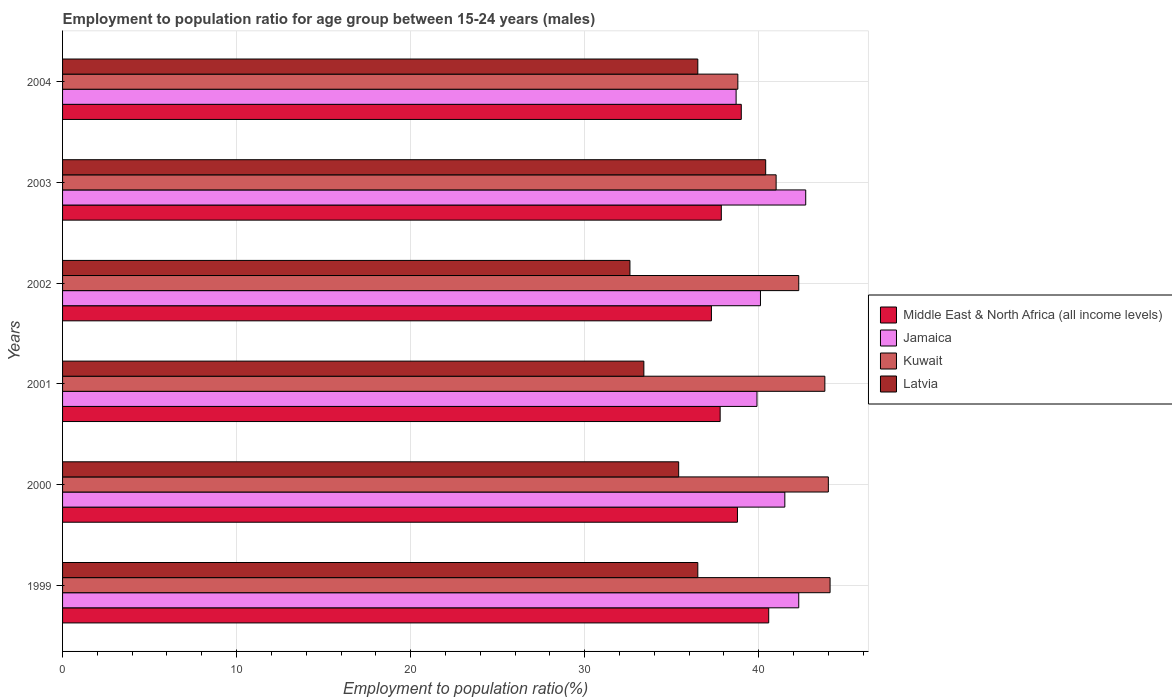How many different coloured bars are there?
Make the answer very short. 4. How many groups of bars are there?
Provide a succinct answer. 6. Are the number of bars on each tick of the Y-axis equal?
Offer a terse response. Yes. What is the label of the 2nd group of bars from the top?
Ensure brevity in your answer.  2003. In how many cases, is the number of bars for a given year not equal to the number of legend labels?
Your answer should be very brief. 0. What is the employment to population ratio in Kuwait in 2003?
Provide a succinct answer. 41. Across all years, what is the maximum employment to population ratio in Middle East & North Africa (all income levels)?
Ensure brevity in your answer.  40.57. Across all years, what is the minimum employment to population ratio in Middle East & North Africa (all income levels)?
Provide a succinct answer. 37.28. In which year was the employment to population ratio in Jamaica minimum?
Keep it short and to the point. 2004. What is the total employment to population ratio in Jamaica in the graph?
Provide a short and direct response. 245.2. What is the difference between the employment to population ratio in Kuwait in 2002 and that in 2003?
Provide a succinct answer. 1.3. What is the difference between the employment to population ratio in Kuwait in 2004 and the employment to population ratio in Latvia in 1999?
Offer a very short reply. 2.3. What is the average employment to population ratio in Latvia per year?
Keep it short and to the point. 35.8. In the year 2003, what is the difference between the employment to population ratio in Middle East & North Africa (all income levels) and employment to population ratio in Kuwait?
Your answer should be compact. -3.15. In how many years, is the employment to population ratio in Latvia greater than 42 %?
Give a very brief answer. 0. What is the ratio of the employment to population ratio in Jamaica in 2002 to that in 2004?
Keep it short and to the point. 1.04. Is the employment to population ratio in Kuwait in 2000 less than that in 2002?
Make the answer very short. No. What is the difference between the highest and the second highest employment to population ratio in Middle East & North Africa (all income levels)?
Give a very brief answer. 1.58. What is the difference between the highest and the lowest employment to population ratio in Latvia?
Offer a terse response. 7.8. Is the sum of the employment to population ratio in Jamaica in 2000 and 2004 greater than the maximum employment to population ratio in Middle East & North Africa (all income levels) across all years?
Provide a succinct answer. Yes. Is it the case that in every year, the sum of the employment to population ratio in Latvia and employment to population ratio in Kuwait is greater than the sum of employment to population ratio in Middle East & North Africa (all income levels) and employment to population ratio in Jamaica?
Provide a short and direct response. No. What does the 4th bar from the top in 2003 represents?
Provide a short and direct response. Middle East & North Africa (all income levels). What does the 3rd bar from the bottom in 2000 represents?
Offer a terse response. Kuwait. Is it the case that in every year, the sum of the employment to population ratio in Jamaica and employment to population ratio in Latvia is greater than the employment to population ratio in Middle East & North Africa (all income levels)?
Keep it short and to the point. Yes. What is the difference between two consecutive major ticks on the X-axis?
Offer a very short reply. 10. Does the graph contain any zero values?
Your answer should be compact. No. Does the graph contain grids?
Ensure brevity in your answer.  Yes. What is the title of the graph?
Provide a short and direct response. Employment to population ratio for age group between 15-24 years (males). What is the label or title of the Y-axis?
Your answer should be compact. Years. What is the Employment to population ratio(%) in Middle East & North Africa (all income levels) in 1999?
Keep it short and to the point. 40.57. What is the Employment to population ratio(%) in Jamaica in 1999?
Ensure brevity in your answer.  42.3. What is the Employment to population ratio(%) of Kuwait in 1999?
Offer a terse response. 44.1. What is the Employment to population ratio(%) in Latvia in 1999?
Provide a succinct answer. 36.5. What is the Employment to population ratio(%) in Middle East & North Africa (all income levels) in 2000?
Your answer should be very brief. 38.78. What is the Employment to population ratio(%) of Jamaica in 2000?
Provide a short and direct response. 41.5. What is the Employment to population ratio(%) in Kuwait in 2000?
Offer a terse response. 44. What is the Employment to population ratio(%) in Latvia in 2000?
Give a very brief answer. 35.4. What is the Employment to population ratio(%) in Middle East & North Africa (all income levels) in 2001?
Provide a succinct answer. 37.78. What is the Employment to population ratio(%) in Jamaica in 2001?
Keep it short and to the point. 39.9. What is the Employment to population ratio(%) of Kuwait in 2001?
Ensure brevity in your answer.  43.8. What is the Employment to population ratio(%) in Latvia in 2001?
Offer a terse response. 33.4. What is the Employment to population ratio(%) in Middle East & North Africa (all income levels) in 2002?
Give a very brief answer. 37.28. What is the Employment to population ratio(%) of Jamaica in 2002?
Offer a terse response. 40.1. What is the Employment to population ratio(%) in Kuwait in 2002?
Your answer should be compact. 42.3. What is the Employment to population ratio(%) in Latvia in 2002?
Provide a short and direct response. 32.6. What is the Employment to population ratio(%) of Middle East & North Africa (all income levels) in 2003?
Offer a terse response. 37.85. What is the Employment to population ratio(%) of Jamaica in 2003?
Keep it short and to the point. 42.7. What is the Employment to population ratio(%) of Kuwait in 2003?
Your answer should be very brief. 41. What is the Employment to population ratio(%) in Latvia in 2003?
Offer a terse response. 40.4. What is the Employment to population ratio(%) of Middle East & North Africa (all income levels) in 2004?
Make the answer very short. 39. What is the Employment to population ratio(%) of Jamaica in 2004?
Provide a short and direct response. 38.7. What is the Employment to population ratio(%) of Kuwait in 2004?
Your answer should be very brief. 38.8. What is the Employment to population ratio(%) in Latvia in 2004?
Ensure brevity in your answer.  36.5. Across all years, what is the maximum Employment to population ratio(%) of Middle East & North Africa (all income levels)?
Your response must be concise. 40.57. Across all years, what is the maximum Employment to population ratio(%) of Jamaica?
Provide a succinct answer. 42.7. Across all years, what is the maximum Employment to population ratio(%) of Kuwait?
Provide a succinct answer. 44.1. Across all years, what is the maximum Employment to population ratio(%) in Latvia?
Your response must be concise. 40.4. Across all years, what is the minimum Employment to population ratio(%) of Middle East & North Africa (all income levels)?
Your response must be concise. 37.28. Across all years, what is the minimum Employment to population ratio(%) of Jamaica?
Your answer should be very brief. 38.7. Across all years, what is the minimum Employment to population ratio(%) in Kuwait?
Provide a short and direct response. 38.8. Across all years, what is the minimum Employment to population ratio(%) of Latvia?
Make the answer very short. 32.6. What is the total Employment to population ratio(%) of Middle East & North Africa (all income levels) in the graph?
Offer a terse response. 231.26. What is the total Employment to population ratio(%) of Jamaica in the graph?
Your response must be concise. 245.2. What is the total Employment to population ratio(%) in Kuwait in the graph?
Make the answer very short. 254. What is the total Employment to population ratio(%) of Latvia in the graph?
Make the answer very short. 214.8. What is the difference between the Employment to population ratio(%) in Middle East & North Africa (all income levels) in 1999 and that in 2000?
Keep it short and to the point. 1.8. What is the difference between the Employment to population ratio(%) of Jamaica in 1999 and that in 2000?
Offer a very short reply. 0.8. What is the difference between the Employment to population ratio(%) in Middle East & North Africa (all income levels) in 1999 and that in 2001?
Provide a succinct answer. 2.79. What is the difference between the Employment to population ratio(%) of Jamaica in 1999 and that in 2001?
Give a very brief answer. 2.4. What is the difference between the Employment to population ratio(%) of Kuwait in 1999 and that in 2001?
Ensure brevity in your answer.  0.3. What is the difference between the Employment to population ratio(%) in Middle East & North Africa (all income levels) in 1999 and that in 2002?
Make the answer very short. 3.29. What is the difference between the Employment to population ratio(%) of Jamaica in 1999 and that in 2002?
Offer a terse response. 2.2. What is the difference between the Employment to population ratio(%) of Kuwait in 1999 and that in 2002?
Keep it short and to the point. 1.8. What is the difference between the Employment to population ratio(%) of Latvia in 1999 and that in 2002?
Your response must be concise. 3.9. What is the difference between the Employment to population ratio(%) of Middle East & North Africa (all income levels) in 1999 and that in 2003?
Your answer should be very brief. 2.72. What is the difference between the Employment to population ratio(%) of Jamaica in 1999 and that in 2003?
Provide a short and direct response. -0.4. What is the difference between the Employment to population ratio(%) of Middle East & North Africa (all income levels) in 1999 and that in 2004?
Provide a short and direct response. 1.58. What is the difference between the Employment to population ratio(%) of Kuwait in 1999 and that in 2004?
Provide a succinct answer. 5.3. What is the difference between the Employment to population ratio(%) of Latvia in 1999 and that in 2004?
Provide a succinct answer. 0. What is the difference between the Employment to population ratio(%) in Jamaica in 2000 and that in 2001?
Your response must be concise. 1.6. What is the difference between the Employment to population ratio(%) in Latvia in 2000 and that in 2001?
Ensure brevity in your answer.  2. What is the difference between the Employment to population ratio(%) of Middle East & North Africa (all income levels) in 2000 and that in 2002?
Your answer should be compact. 1.5. What is the difference between the Employment to population ratio(%) of Jamaica in 2000 and that in 2002?
Provide a succinct answer. 1.4. What is the difference between the Employment to population ratio(%) in Kuwait in 2000 and that in 2002?
Offer a very short reply. 1.7. What is the difference between the Employment to population ratio(%) of Latvia in 2000 and that in 2002?
Your answer should be compact. 2.8. What is the difference between the Employment to population ratio(%) of Middle East & North Africa (all income levels) in 2000 and that in 2003?
Keep it short and to the point. 0.93. What is the difference between the Employment to population ratio(%) of Latvia in 2000 and that in 2003?
Provide a short and direct response. -5. What is the difference between the Employment to population ratio(%) in Middle East & North Africa (all income levels) in 2000 and that in 2004?
Offer a terse response. -0.22. What is the difference between the Employment to population ratio(%) of Kuwait in 2000 and that in 2004?
Keep it short and to the point. 5.2. What is the difference between the Employment to population ratio(%) in Middle East & North Africa (all income levels) in 2001 and that in 2002?
Keep it short and to the point. 0.5. What is the difference between the Employment to population ratio(%) of Latvia in 2001 and that in 2002?
Make the answer very short. 0.8. What is the difference between the Employment to population ratio(%) of Middle East & North Africa (all income levels) in 2001 and that in 2003?
Your response must be concise. -0.07. What is the difference between the Employment to population ratio(%) of Kuwait in 2001 and that in 2003?
Ensure brevity in your answer.  2.8. What is the difference between the Employment to population ratio(%) of Middle East & North Africa (all income levels) in 2001 and that in 2004?
Your answer should be compact. -1.21. What is the difference between the Employment to population ratio(%) of Jamaica in 2001 and that in 2004?
Give a very brief answer. 1.2. What is the difference between the Employment to population ratio(%) in Middle East & North Africa (all income levels) in 2002 and that in 2003?
Ensure brevity in your answer.  -0.57. What is the difference between the Employment to population ratio(%) of Kuwait in 2002 and that in 2003?
Offer a very short reply. 1.3. What is the difference between the Employment to population ratio(%) of Latvia in 2002 and that in 2003?
Make the answer very short. -7.8. What is the difference between the Employment to population ratio(%) of Middle East & North Africa (all income levels) in 2002 and that in 2004?
Make the answer very short. -1.72. What is the difference between the Employment to population ratio(%) in Jamaica in 2002 and that in 2004?
Ensure brevity in your answer.  1.4. What is the difference between the Employment to population ratio(%) in Kuwait in 2002 and that in 2004?
Offer a very short reply. 3.5. What is the difference between the Employment to population ratio(%) in Latvia in 2002 and that in 2004?
Provide a succinct answer. -3.9. What is the difference between the Employment to population ratio(%) in Middle East & North Africa (all income levels) in 2003 and that in 2004?
Ensure brevity in your answer.  -1.15. What is the difference between the Employment to population ratio(%) of Jamaica in 2003 and that in 2004?
Your answer should be compact. 4. What is the difference between the Employment to population ratio(%) in Middle East & North Africa (all income levels) in 1999 and the Employment to population ratio(%) in Jamaica in 2000?
Make the answer very short. -0.93. What is the difference between the Employment to population ratio(%) of Middle East & North Africa (all income levels) in 1999 and the Employment to population ratio(%) of Kuwait in 2000?
Give a very brief answer. -3.43. What is the difference between the Employment to population ratio(%) of Middle East & North Africa (all income levels) in 1999 and the Employment to population ratio(%) of Latvia in 2000?
Provide a short and direct response. 5.17. What is the difference between the Employment to population ratio(%) of Jamaica in 1999 and the Employment to population ratio(%) of Latvia in 2000?
Your response must be concise. 6.9. What is the difference between the Employment to population ratio(%) of Kuwait in 1999 and the Employment to population ratio(%) of Latvia in 2000?
Offer a terse response. 8.7. What is the difference between the Employment to population ratio(%) of Middle East & North Africa (all income levels) in 1999 and the Employment to population ratio(%) of Jamaica in 2001?
Make the answer very short. 0.67. What is the difference between the Employment to population ratio(%) in Middle East & North Africa (all income levels) in 1999 and the Employment to population ratio(%) in Kuwait in 2001?
Your answer should be very brief. -3.23. What is the difference between the Employment to population ratio(%) in Middle East & North Africa (all income levels) in 1999 and the Employment to population ratio(%) in Latvia in 2001?
Ensure brevity in your answer.  7.17. What is the difference between the Employment to population ratio(%) in Jamaica in 1999 and the Employment to population ratio(%) in Latvia in 2001?
Ensure brevity in your answer.  8.9. What is the difference between the Employment to population ratio(%) in Middle East & North Africa (all income levels) in 1999 and the Employment to population ratio(%) in Jamaica in 2002?
Make the answer very short. 0.47. What is the difference between the Employment to population ratio(%) in Middle East & North Africa (all income levels) in 1999 and the Employment to population ratio(%) in Kuwait in 2002?
Your answer should be very brief. -1.73. What is the difference between the Employment to population ratio(%) of Middle East & North Africa (all income levels) in 1999 and the Employment to population ratio(%) of Latvia in 2002?
Your answer should be very brief. 7.97. What is the difference between the Employment to population ratio(%) of Kuwait in 1999 and the Employment to population ratio(%) of Latvia in 2002?
Ensure brevity in your answer.  11.5. What is the difference between the Employment to population ratio(%) of Middle East & North Africa (all income levels) in 1999 and the Employment to population ratio(%) of Jamaica in 2003?
Your response must be concise. -2.13. What is the difference between the Employment to population ratio(%) of Middle East & North Africa (all income levels) in 1999 and the Employment to population ratio(%) of Kuwait in 2003?
Provide a succinct answer. -0.43. What is the difference between the Employment to population ratio(%) in Middle East & North Africa (all income levels) in 1999 and the Employment to population ratio(%) in Latvia in 2003?
Provide a succinct answer. 0.17. What is the difference between the Employment to population ratio(%) of Jamaica in 1999 and the Employment to population ratio(%) of Kuwait in 2003?
Offer a terse response. 1.3. What is the difference between the Employment to population ratio(%) of Jamaica in 1999 and the Employment to population ratio(%) of Latvia in 2003?
Keep it short and to the point. 1.9. What is the difference between the Employment to population ratio(%) of Middle East & North Africa (all income levels) in 1999 and the Employment to population ratio(%) of Jamaica in 2004?
Offer a terse response. 1.87. What is the difference between the Employment to population ratio(%) in Middle East & North Africa (all income levels) in 1999 and the Employment to population ratio(%) in Kuwait in 2004?
Provide a short and direct response. 1.77. What is the difference between the Employment to population ratio(%) in Middle East & North Africa (all income levels) in 1999 and the Employment to population ratio(%) in Latvia in 2004?
Give a very brief answer. 4.07. What is the difference between the Employment to population ratio(%) in Jamaica in 1999 and the Employment to population ratio(%) in Latvia in 2004?
Give a very brief answer. 5.8. What is the difference between the Employment to population ratio(%) in Middle East & North Africa (all income levels) in 2000 and the Employment to population ratio(%) in Jamaica in 2001?
Provide a short and direct response. -1.12. What is the difference between the Employment to population ratio(%) of Middle East & North Africa (all income levels) in 2000 and the Employment to population ratio(%) of Kuwait in 2001?
Offer a terse response. -5.02. What is the difference between the Employment to population ratio(%) of Middle East & North Africa (all income levels) in 2000 and the Employment to population ratio(%) of Latvia in 2001?
Your response must be concise. 5.38. What is the difference between the Employment to population ratio(%) of Middle East & North Africa (all income levels) in 2000 and the Employment to population ratio(%) of Jamaica in 2002?
Your answer should be very brief. -1.32. What is the difference between the Employment to population ratio(%) of Middle East & North Africa (all income levels) in 2000 and the Employment to population ratio(%) of Kuwait in 2002?
Offer a very short reply. -3.52. What is the difference between the Employment to population ratio(%) in Middle East & North Africa (all income levels) in 2000 and the Employment to population ratio(%) in Latvia in 2002?
Ensure brevity in your answer.  6.18. What is the difference between the Employment to population ratio(%) of Jamaica in 2000 and the Employment to population ratio(%) of Kuwait in 2002?
Make the answer very short. -0.8. What is the difference between the Employment to population ratio(%) in Jamaica in 2000 and the Employment to population ratio(%) in Latvia in 2002?
Make the answer very short. 8.9. What is the difference between the Employment to population ratio(%) of Kuwait in 2000 and the Employment to population ratio(%) of Latvia in 2002?
Your answer should be very brief. 11.4. What is the difference between the Employment to population ratio(%) of Middle East & North Africa (all income levels) in 2000 and the Employment to population ratio(%) of Jamaica in 2003?
Your response must be concise. -3.92. What is the difference between the Employment to population ratio(%) of Middle East & North Africa (all income levels) in 2000 and the Employment to population ratio(%) of Kuwait in 2003?
Make the answer very short. -2.22. What is the difference between the Employment to population ratio(%) of Middle East & North Africa (all income levels) in 2000 and the Employment to population ratio(%) of Latvia in 2003?
Ensure brevity in your answer.  -1.62. What is the difference between the Employment to population ratio(%) in Jamaica in 2000 and the Employment to population ratio(%) in Latvia in 2003?
Provide a succinct answer. 1.1. What is the difference between the Employment to population ratio(%) of Middle East & North Africa (all income levels) in 2000 and the Employment to population ratio(%) of Jamaica in 2004?
Your response must be concise. 0.08. What is the difference between the Employment to population ratio(%) in Middle East & North Africa (all income levels) in 2000 and the Employment to population ratio(%) in Kuwait in 2004?
Your response must be concise. -0.02. What is the difference between the Employment to population ratio(%) in Middle East & North Africa (all income levels) in 2000 and the Employment to population ratio(%) in Latvia in 2004?
Make the answer very short. 2.28. What is the difference between the Employment to population ratio(%) of Jamaica in 2000 and the Employment to population ratio(%) of Kuwait in 2004?
Make the answer very short. 2.7. What is the difference between the Employment to population ratio(%) in Jamaica in 2000 and the Employment to population ratio(%) in Latvia in 2004?
Keep it short and to the point. 5. What is the difference between the Employment to population ratio(%) in Middle East & North Africa (all income levels) in 2001 and the Employment to population ratio(%) in Jamaica in 2002?
Your answer should be compact. -2.32. What is the difference between the Employment to population ratio(%) in Middle East & North Africa (all income levels) in 2001 and the Employment to population ratio(%) in Kuwait in 2002?
Keep it short and to the point. -4.52. What is the difference between the Employment to population ratio(%) of Middle East & North Africa (all income levels) in 2001 and the Employment to population ratio(%) of Latvia in 2002?
Offer a very short reply. 5.18. What is the difference between the Employment to population ratio(%) of Jamaica in 2001 and the Employment to population ratio(%) of Latvia in 2002?
Your answer should be compact. 7.3. What is the difference between the Employment to population ratio(%) in Middle East & North Africa (all income levels) in 2001 and the Employment to population ratio(%) in Jamaica in 2003?
Ensure brevity in your answer.  -4.92. What is the difference between the Employment to population ratio(%) of Middle East & North Africa (all income levels) in 2001 and the Employment to population ratio(%) of Kuwait in 2003?
Offer a very short reply. -3.22. What is the difference between the Employment to population ratio(%) of Middle East & North Africa (all income levels) in 2001 and the Employment to population ratio(%) of Latvia in 2003?
Your answer should be very brief. -2.62. What is the difference between the Employment to population ratio(%) of Jamaica in 2001 and the Employment to population ratio(%) of Kuwait in 2003?
Ensure brevity in your answer.  -1.1. What is the difference between the Employment to population ratio(%) in Middle East & North Africa (all income levels) in 2001 and the Employment to population ratio(%) in Jamaica in 2004?
Your response must be concise. -0.92. What is the difference between the Employment to population ratio(%) of Middle East & North Africa (all income levels) in 2001 and the Employment to population ratio(%) of Kuwait in 2004?
Ensure brevity in your answer.  -1.02. What is the difference between the Employment to population ratio(%) in Middle East & North Africa (all income levels) in 2001 and the Employment to population ratio(%) in Latvia in 2004?
Your response must be concise. 1.28. What is the difference between the Employment to population ratio(%) in Middle East & North Africa (all income levels) in 2002 and the Employment to population ratio(%) in Jamaica in 2003?
Ensure brevity in your answer.  -5.42. What is the difference between the Employment to population ratio(%) in Middle East & North Africa (all income levels) in 2002 and the Employment to population ratio(%) in Kuwait in 2003?
Offer a very short reply. -3.72. What is the difference between the Employment to population ratio(%) of Middle East & North Africa (all income levels) in 2002 and the Employment to population ratio(%) of Latvia in 2003?
Give a very brief answer. -3.12. What is the difference between the Employment to population ratio(%) of Middle East & North Africa (all income levels) in 2002 and the Employment to population ratio(%) of Jamaica in 2004?
Offer a terse response. -1.42. What is the difference between the Employment to population ratio(%) in Middle East & North Africa (all income levels) in 2002 and the Employment to population ratio(%) in Kuwait in 2004?
Offer a terse response. -1.52. What is the difference between the Employment to population ratio(%) of Middle East & North Africa (all income levels) in 2002 and the Employment to population ratio(%) of Latvia in 2004?
Offer a terse response. 0.78. What is the difference between the Employment to population ratio(%) in Jamaica in 2002 and the Employment to population ratio(%) in Kuwait in 2004?
Offer a very short reply. 1.3. What is the difference between the Employment to population ratio(%) in Jamaica in 2002 and the Employment to population ratio(%) in Latvia in 2004?
Give a very brief answer. 3.6. What is the difference between the Employment to population ratio(%) of Kuwait in 2002 and the Employment to population ratio(%) of Latvia in 2004?
Ensure brevity in your answer.  5.8. What is the difference between the Employment to population ratio(%) of Middle East & North Africa (all income levels) in 2003 and the Employment to population ratio(%) of Jamaica in 2004?
Offer a very short reply. -0.85. What is the difference between the Employment to population ratio(%) in Middle East & North Africa (all income levels) in 2003 and the Employment to population ratio(%) in Kuwait in 2004?
Provide a succinct answer. -0.95. What is the difference between the Employment to population ratio(%) of Middle East & North Africa (all income levels) in 2003 and the Employment to population ratio(%) of Latvia in 2004?
Ensure brevity in your answer.  1.35. What is the difference between the Employment to population ratio(%) of Jamaica in 2003 and the Employment to population ratio(%) of Kuwait in 2004?
Your response must be concise. 3.9. What is the difference between the Employment to population ratio(%) of Jamaica in 2003 and the Employment to population ratio(%) of Latvia in 2004?
Ensure brevity in your answer.  6.2. What is the average Employment to population ratio(%) in Middle East & North Africa (all income levels) per year?
Provide a succinct answer. 38.54. What is the average Employment to population ratio(%) of Jamaica per year?
Ensure brevity in your answer.  40.87. What is the average Employment to population ratio(%) in Kuwait per year?
Provide a succinct answer. 42.33. What is the average Employment to population ratio(%) of Latvia per year?
Your answer should be compact. 35.8. In the year 1999, what is the difference between the Employment to population ratio(%) of Middle East & North Africa (all income levels) and Employment to population ratio(%) of Jamaica?
Make the answer very short. -1.73. In the year 1999, what is the difference between the Employment to population ratio(%) of Middle East & North Africa (all income levels) and Employment to population ratio(%) of Kuwait?
Offer a terse response. -3.53. In the year 1999, what is the difference between the Employment to population ratio(%) of Middle East & North Africa (all income levels) and Employment to population ratio(%) of Latvia?
Your response must be concise. 4.07. In the year 1999, what is the difference between the Employment to population ratio(%) in Jamaica and Employment to population ratio(%) in Kuwait?
Provide a succinct answer. -1.8. In the year 1999, what is the difference between the Employment to population ratio(%) in Jamaica and Employment to population ratio(%) in Latvia?
Provide a succinct answer. 5.8. In the year 2000, what is the difference between the Employment to population ratio(%) of Middle East & North Africa (all income levels) and Employment to population ratio(%) of Jamaica?
Keep it short and to the point. -2.72. In the year 2000, what is the difference between the Employment to population ratio(%) of Middle East & North Africa (all income levels) and Employment to population ratio(%) of Kuwait?
Keep it short and to the point. -5.22. In the year 2000, what is the difference between the Employment to population ratio(%) in Middle East & North Africa (all income levels) and Employment to population ratio(%) in Latvia?
Your answer should be very brief. 3.38. In the year 2000, what is the difference between the Employment to population ratio(%) of Jamaica and Employment to population ratio(%) of Kuwait?
Provide a short and direct response. -2.5. In the year 2000, what is the difference between the Employment to population ratio(%) of Jamaica and Employment to population ratio(%) of Latvia?
Your answer should be compact. 6.1. In the year 2001, what is the difference between the Employment to population ratio(%) of Middle East & North Africa (all income levels) and Employment to population ratio(%) of Jamaica?
Provide a succinct answer. -2.12. In the year 2001, what is the difference between the Employment to population ratio(%) of Middle East & North Africa (all income levels) and Employment to population ratio(%) of Kuwait?
Provide a short and direct response. -6.02. In the year 2001, what is the difference between the Employment to population ratio(%) of Middle East & North Africa (all income levels) and Employment to population ratio(%) of Latvia?
Offer a terse response. 4.38. In the year 2001, what is the difference between the Employment to population ratio(%) in Jamaica and Employment to population ratio(%) in Kuwait?
Make the answer very short. -3.9. In the year 2001, what is the difference between the Employment to population ratio(%) of Jamaica and Employment to population ratio(%) of Latvia?
Offer a very short reply. 6.5. In the year 2002, what is the difference between the Employment to population ratio(%) of Middle East & North Africa (all income levels) and Employment to population ratio(%) of Jamaica?
Make the answer very short. -2.82. In the year 2002, what is the difference between the Employment to population ratio(%) of Middle East & North Africa (all income levels) and Employment to population ratio(%) of Kuwait?
Your answer should be compact. -5.02. In the year 2002, what is the difference between the Employment to population ratio(%) in Middle East & North Africa (all income levels) and Employment to population ratio(%) in Latvia?
Make the answer very short. 4.68. In the year 2002, what is the difference between the Employment to population ratio(%) in Jamaica and Employment to population ratio(%) in Kuwait?
Give a very brief answer. -2.2. In the year 2002, what is the difference between the Employment to population ratio(%) of Kuwait and Employment to population ratio(%) of Latvia?
Your answer should be very brief. 9.7. In the year 2003, what is the difference between the Employment to population ratio(%) in Middle East & North Africa (all income levels) and Employment to population ratio(%) in Jamaica?
Give a very brief answer. -4.85. In the year 2003, what is the difference between the Employment to population ratio(%) of Middle East & North Africa (all income levels) and Employment to population ratio(%) of Kuwait?
Offer a very short reply. -3.15. In the year 2003, what is the difference between the Employment to population ratio(%) of Middle East & North Africa (all income levels) and Employment to population ratio(%) of Latvia?
Offer a very short reply. -2.55. In the year 2003, what is the difference between the Employment to population ratio(%) of Jamaica and Employment to population ratio(%) of Kuwait?
Provide a succinct answer. 1.7. In the year 2003, what is the difference between the Employment to population ratio(%) of Jamaica and Employment to population ratio(%) of Latvia?
Your response must be concise. 2.3. In the year 2004, what is the difference between the Employment to population ratio(%) in Middle East & North Africa (all income levels) and Employment to population ratio(%) in Jamaica?
Ensure brevity in your answer.  0.3. In the year 2004, what is the difference between the Employment to population ratio(%) in Middle East & North Africa (all income levels) and Employment to population ratio(%) in Kuwait?
Keep it short and to the point. 0.2. In the year 2004, what is the difference between the Employment to population ratio(%) of Middle East & North Africa (all income levels) and Employment to population ratio(%) of Latvia?
Offer a terse response. 2.5. In the year 2004, what is the difference between the Employment to population ratio(%) of Jamaica and Employment to population ratio(%) of Latvia?
Ensure brevity in your answer.  2.2. In the year 2004, what is the difference between the Employment to population ratio(%) of Kuwait and Employment to population ratio(%) of Latvia?
Provide a succinct answer. 2.3. What is the ratio of the Employment to population ratio(%) in Middle East & North Africa (all income levels) in 1999 to that in 2000?
Provide a succinct answer. 1.05. What is the ratio of the Employment to population ratio(%) of Jamaica in 1999 to that in 2000?
Offer a terse response. 1.02. What is the ratio of the Employment to population ratio(%) of Latvia in 1999 to that in 2000?
Provide a succinct answer. 1.03. What is the ratio of the Employment to population ratio(%) of Middle East & North Africa (all income levels) in 1999 to that in 2001?
Make the answer very short. 1.07. What is the ratio of the Employment to population ratio(%) in Jamaica in 1999 to that in 2001?
Keep it short and to the point. 1.06. What is the ratio of the Employment to population ratio(%) of Kuwait in 1999 to that in 2001?
Provide a short and direct response. 1.01. What is the ratio of the Employment to population ratio(%) of Latvia in 1999 to that in 2001?
Ensure brevity in your answer.  1.09. What is the ratio of the Employment to population ratio(%) in Middle East & North Africa (all income levels) in 1999 to that in 2002?
Your response must be concise. 1.09. What is the ratio of the Employment to population ratio(%) in Jamaica in 1999 to that in 2002?
Your answer should be very brief. 1.05. What is the ratio of the Employment to population ratio(%) in Kuwait in 1999 to that in 2002?
Offer a very short reply. 1.04. What is the ratio of the Employment to population ratio(%) of Latvia in 1999 to that in 2002?
Your answer should be compact. 1.12. What is the ratio of the Employment to population ratio(%) in Middle East & North Africa (all income levels) in 1999 to that in 2003?
Keep it short and to the point. 1.07. What is the ratio of the Employment to population ratio(%) in Jamaica in 1999 to that in 2003?
Offer a terse response. 0.99. What is the ratio of the Employment to population ratio(%) of Kuwait in 1999 to that in 2003?
Keep it short and to the point. 1.08. What is the ratio of the Employment to population ratio(%) of Latvia in 1999 to that in 2003?
Provide a succinct answer. 0.9. What is the ratio of the Employment to population ratio(%) of Middle East & North Africa (all income levels) in 1999 to that in 2004?
Your answer should be very brief. 1.04. What is the ratio of the Employment to population ratio(%) of Jamaica in 1999 to that in 2004?
Your answer should be compact. 1.09. What is the ratio of the Employment to population ratio(%) of Kuwait in 1999 to that in 2004?
Make the answer very short. 1.14. What is the ratio of the Employment to population ratio(%) of Middle East & North Africa (all income levels) in 2000 to that in 2001?
Provide a succinct answer. 1.03. What is the ratio of the Employment to population ratio(%) of Jamaica in 2000 to that in 2001?
Your response must be concise. 1.04. What is the ratio of the Employment to population ratio(%) in Kuwait in 2000 to that in 2001?
Keep it short and to the point. 1. What is the ratio of the Employment to population ratio(%) in Latvia in 2000 to that in 2001?
Your answer should be compact. 1.06. What is the ratio of the Employment to population ratio(%) of Middle East & North Africa (all income levels) in 2000 to that in 2002?
Your response must be concise. 1.04. What is the ratio of the Employment to population ratio(%) of Jamaica in 2000 to that in 2002?
Ensure brevity in your answer.  1.03. What is the ratio of the Employment to population ratio(%) in Kuwait in 2000 to that in 2002?
Your answer should be very brief. 1.04. What is the ratio of the Employment to population ratio(%) of Latvia in 2000 to that in 2002?
Offer a terse response. 1.09. What is the ratio of the Employment to population ratio(%) in Middle East & North Africa (all income levels) in 2000 to that in 2003?
Provide a short and direct response. 1.02. What is the ratio of the Employment to population ratio(%) of Jamaica in 2000 to that in 2003?
Offer a very short reply. 0.97. What is the ratio of the Employment to population ratio(%) in Kuwait in 2000 to that in 2003?
Give a very brief answer. 1.07. What is the ratio of the Employment to population ratio(%) in Latvia in 2000 to that in 2003?
Make the answer very short. 0.88. What is the ratio of the Employment to population ratio(%) of Middle East & North Africa (all income levels) in 2000 to that in 2004?
Give a very brief answer. 0.99. What is the ratio of the Employment to population ratio(%) of Jamaica in 2000 to that in 2004?
Keep it short and to the point. 1.07. What is the ratio of the Employment to population ratio(%) of Kuwait in 2000 to that in 2004?
Your response must be concise. 1.13. What is the ratio of the Employment to population ratio(%) of Latvia in 2000 to that in 2004?
Your response must be concise. 0.97. What is the ratio of the Employment to population ratio(%) of Middle East & North Africa (all income levels) in 2001 to that in 2002?
Provide a short and direct response. 1.01. What is the ratio of the Employment to population ratio(%) of Jamaica in 2001 to that in 2002?
Your answer should be very brief. 0.99. What is the ratio of the Employment to population ratio(%) in Kuwait in 2001 to that in 2002?
Your answer should be very brief. 1.04. What is the ratio of the Employment to population ratio(%) of Latvia in 2001 to that in 2002?
Provide a short and direct response. 1.02. What is the ratio of the Employment to population ratio(%) of Jamaica in 2001 to that in 2003?
Keep it short and to the point. 0.93. What is the ratio of the Employment to population ratio(%) in Kuwait in 2001 to that in 2003?
Offer a very short reply. 1.07. What is the ratio of the Employment to population ratio(%) in Latvia in 2001 to that in 2003?
Make the answer very short. 0.83. What is the ratio of the Employment to population ratio(%) of Middle East & North Africa (all income levels) in 2001 to that in 2004?
Offer a terse response. 0.97. What is the ratio of the Employment to population ratio(%) in Jamaica in 2001 to that in 2004?
Your response must be concise. 1.03. What is the ratio of the Employment to population ratio(%) in Kuwait in 2001 to that in 2004?
Your answer should be very brief. 1.13. What is the ratio of the Employment to population ratio(%) in Latvia in 2001 to that in 2004?
Make the answer very short. 0.92. What is the ratio of the Employment to population ratio(%) in Middle East & North Africa (all income levels) in 2002 to that in 2003?
Provide a short and direct response. 0.98. What is the ratio of the Employment to population ratio(%) in Jamaica in 2002 to that in 2003?
Give a very brief answer. 0.94. What is the ratio of the Employment to population ratio(%) in Kuwait in 2002 to that in 2003?
Your answer should be very brief. 1.03. What is the ratio of the Employment to population ratio(%) in Latvia in 2002 to that in 2003?
Provide a short and direct response. 0.81. What is the ratio of the Employment to population ratio(%) in Middle East & North Africa (all income levels) in 2002 to that in 2004?
Provide a succinct answer. 0.96. What is the ratio of the Employment to population ratio(%) in Jamaica in 2002 to that in 2004?
Offer a very short reply. 1.04. What is the ratio of the Employment to population ratio(%) in Kuwait in 2002 to that in 2004?
Give a very brief answer. 1.09. What is the ratio of the Employment to population ratio(%) of Latvia in 2002 to that in 2004?
Give a very brief answer. 0.89. What is the ratio of the Employment to population ratio(%) of Middle East & North Africa (all income levels) in 2003 to that in 2004?
Offer a terse response. 0.97. What is the ratio of the Employment to population ratio(%) of Jamaica in 2003 to that in 2004?
Provide a short and direct response. 1.1. What is the ratio of the Employment to population ratio(%) of Kuwait in 2003 to that in 2004?
Offer a terse response. 1.06. What is the ratio of the Employment to population ratio(%) of Latvia in 2003 to that in 2004?
Ensure brevity in your answer.  1.11. What is the difference between the highest and the second highest Employment to population ratio(%) in Middle East & North Africa (all income levels)?
Offer a terse response. 1.58. What is the difference between the highest and the lowest Employment to population ratio(%) in Middle East & North Africa (all income levels)?
Provide a short and direct response. 3.29. What is the difference between the highest and the lowest Employment to population ratio(%) in Jamaica?
Give a very brief answer. 4. What is the difference between the highest and the lowest Employment to population ratio(%) of Kuwait?
Your answer should be very brief. 5.3. 